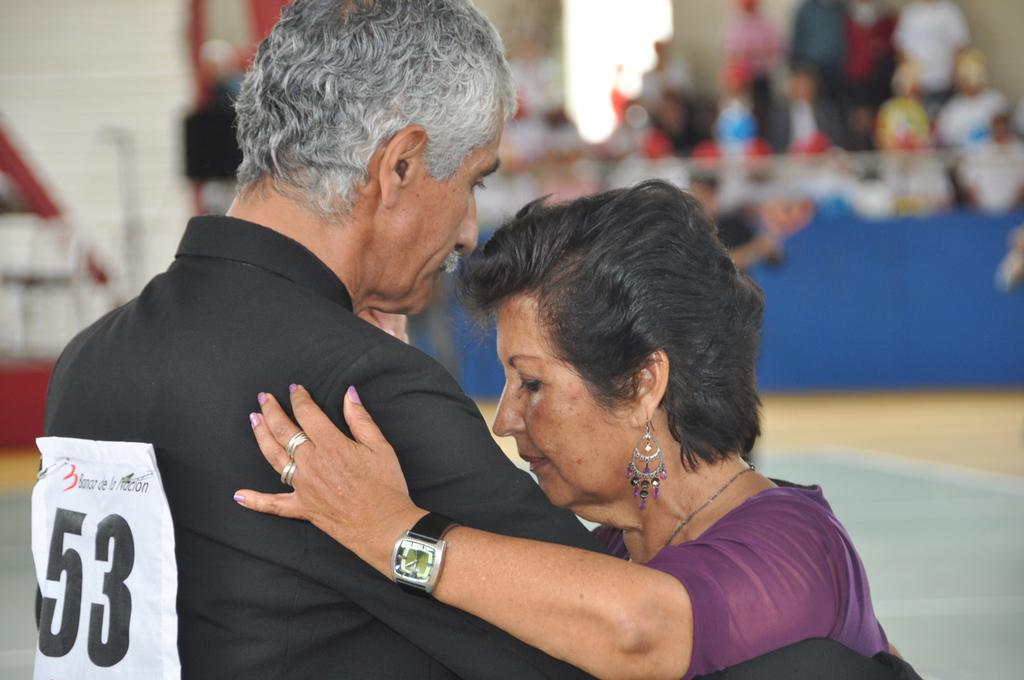<image>
Give a short and clear explanation of the subsequent image. A man is dancing and has the number 53 on his shirt. 